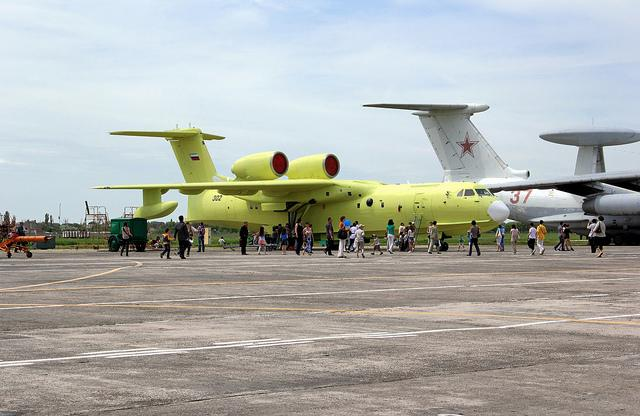What item is painted in an unconventional color?

Choices:
A) balloon
B) nearest plane
C) tarmac
D) farthest plane nearest plane 